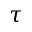<formula> <loc_0><loc_0><loc_500><loc_500>\tau</formula> 